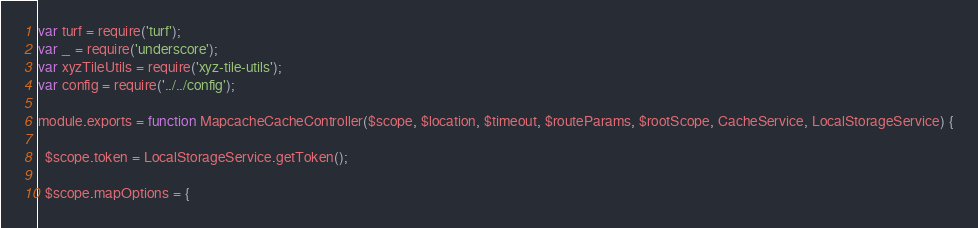<code> <loc_0><loc_0><loc_500><loc_500><_JavaScript_>var turf = require('turf');
var _ = require('underscore');
var xyzTileUtils = require('xyz-tile-utils');
var config = require('../../config');

module.exports = function MapcacheCacheController($scope, $location, $timeout, $routeParams, $rootScope, CacheService, LocalStorageService) {

  $scope.token = LocalStorageService.getToken();

  $scope.mapOptions = {</code> 